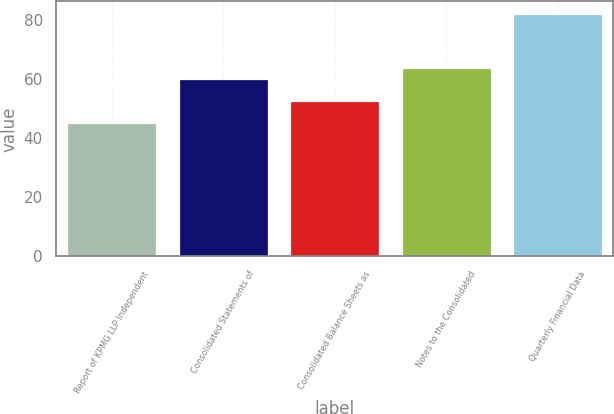<chart> <loc_0><loc_0><loc_500><loc_500><bar_chart><fcel>Report of KPMG LLP Independent<fcel>Consolidated Statements of<fcel>Consolidated Balance Sheets as<fcel>Notes to the Consolidated<fcel>Quarterly Financial Data<nl><fcel>45<fcel>59.8<fcel>52.4<fcel>63.5<fcel>82<nl></chart> 